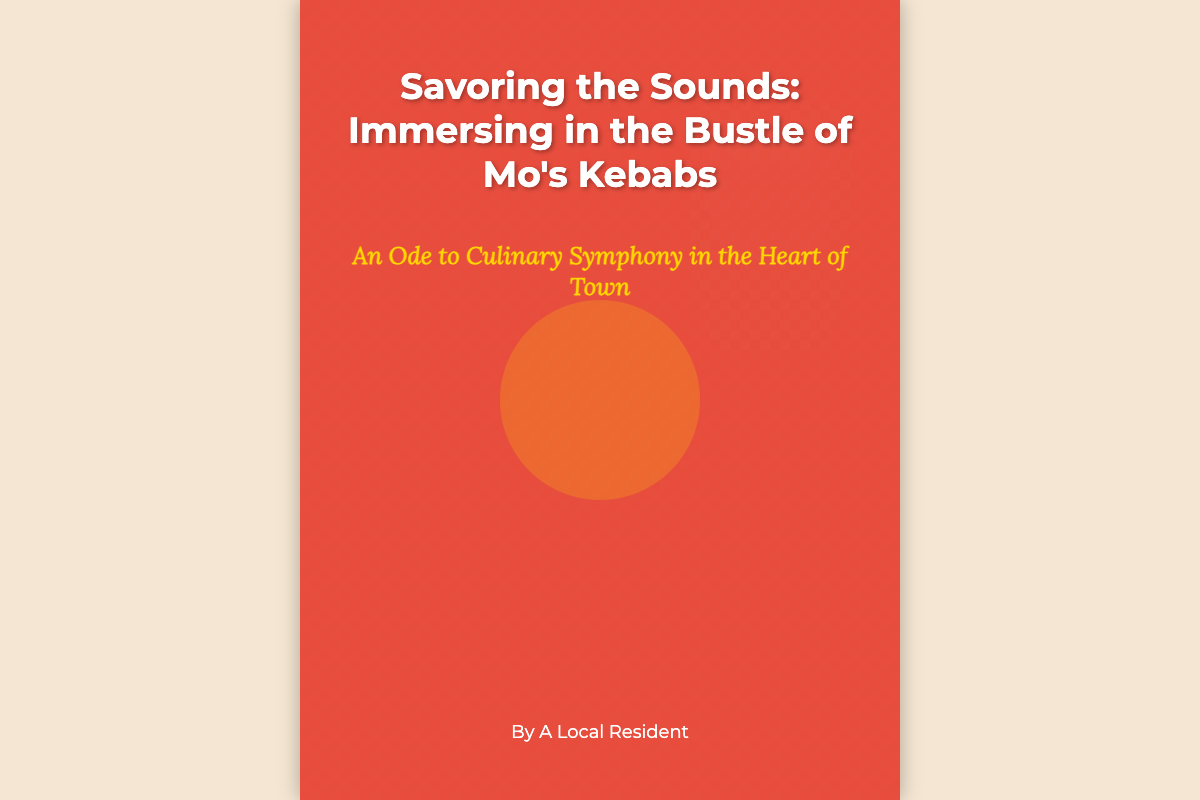What is the title of the book? The title is prominently displayed at the top of the document in a large font.
Answer: Savoring the Sounds: Immersing in the Bustle of Mo's Kebabs Who is the author? The author's name is listed at the bottom of the document.
Answer: A Local Resident What is the subtitle of the book? The subtitle provides additional context and is located below the title.
Answer: An Ode to Culinary Symphony in the Heart of Town What type of establishment is featured on the cover? The text indicates a culinary location that provides a specific food experience.
Answer: Kebab What color is the book cover? The background color of the book cover is a solid, vibrant hue.
Answer: Red How many kebab images are on the cover? There is one specific image that represents the subject matter of the book cover.
Answer: One What is the main theme of the book? The theme is indicated through the title and subtitle, emphasizing auditory experience in a dining environment.
Answer: Culinary Symphony What design element suggests movement on the cover? The animated visual effect in the cover suggests a particular ambiance associated with cooking.
Answer: Smoke What font is used for the title? The title is designed in a specific typeface that emphasizes its importance.
Answer: Montserrat 